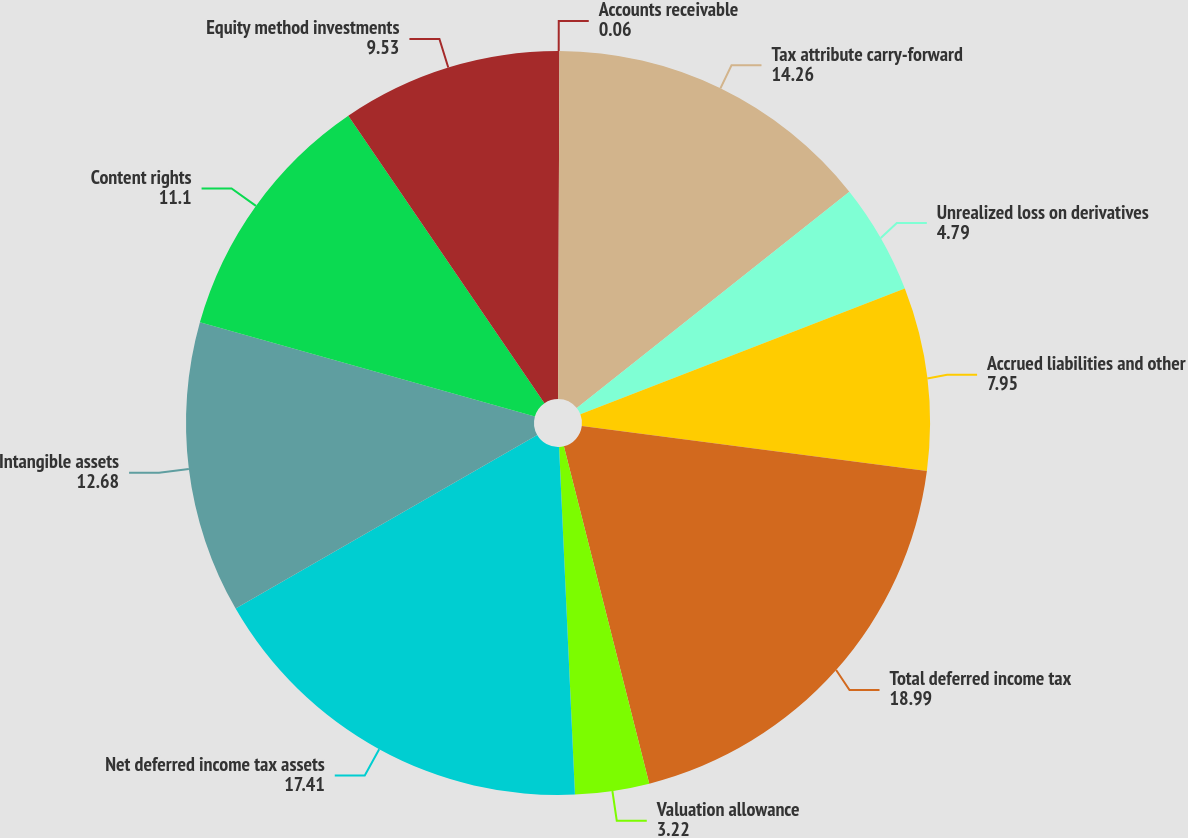Convert chart. <chart><loc_0><loc_0><loc_500><loc_500><pie_chart><fcel>Accounts receivable<fcel>Tax attribute carry-forward<fcel>Unrealized loss on derivatives<fcel>Accrued liabilities and other<fcel>Total deferred income tax<fcel>Valuation allowance<fcel>Net deferred income tax assets<fcel>Intangible assets<fcel>Content rights<fcel>Equity method investments<nl><fcel>0.06%<fcel>14.26%<fcel>4.79%<fcel>7.95%<fcel>18.99%<fcel>3.22%<fcel>17.41%<fcel>12.68%<fcel>11.1%<fcel>9.53%<nl></chart> 